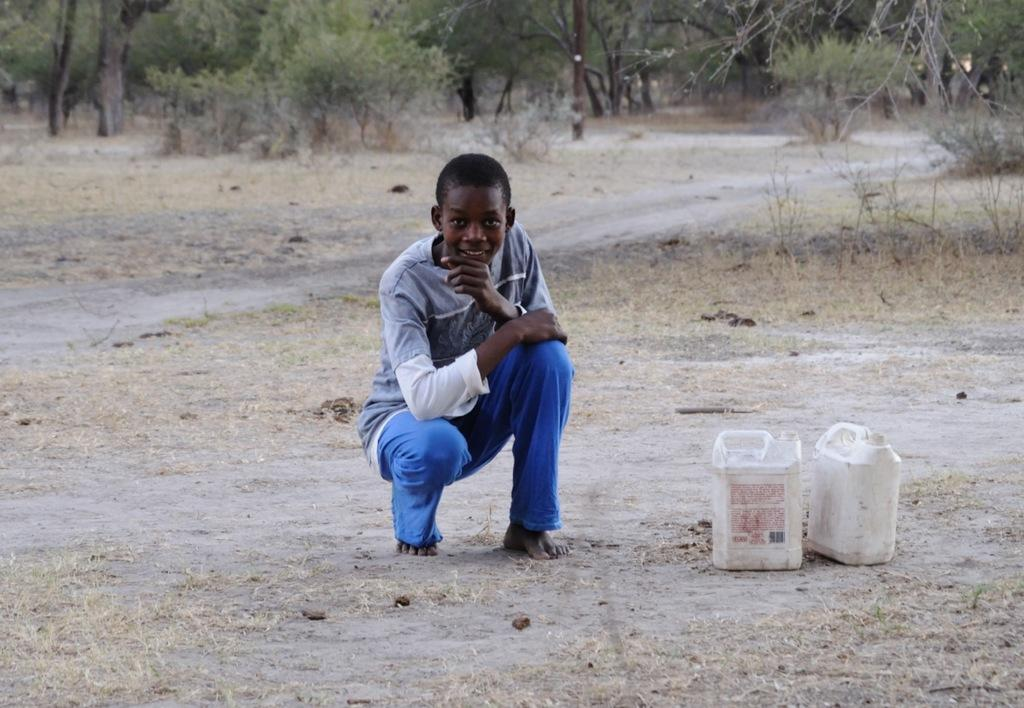What is the person in the image doing? The person is sitting on the ground in the image. What objects can be seen near the person? There are plastic containers in the image. What type of vegetation is present in the image? Bushes and trees are visible in the image. What type of library can be seen in the background of the image? There is no library present in the image; it features a person sitting on the ground, plastic containers, bushes, and trees. Can you tell me how many robins are perched on the trees in the image? There are no robins present in the image; it only features a person sitting on the ground, plastic containers, bushes, and trees. 